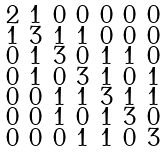<formula> <loc_0><loc_0><loc_500><loc_500>\begin{smallmatrix} 2 & 1 & 0 & 0 & 0 & 0 & 0 \\ 1 & 3 & 1 & 1 & 0 & 0 & 0 \\ 0 & 1 & 3 & 0 & 1 & 1 & 0 \\ 0 & 1 & 0 & 3 & 1 & 0 & 1 \\ 0 & 0 & 1 & 1 & 3 & 1 & 1 \\ 0 & 0 & 1 & 0 & 1 & 3 & 0 \\ 0 & 0 & 0 & 1 & 1 & 0 & 3 \end{smallmatrix}</formula> 